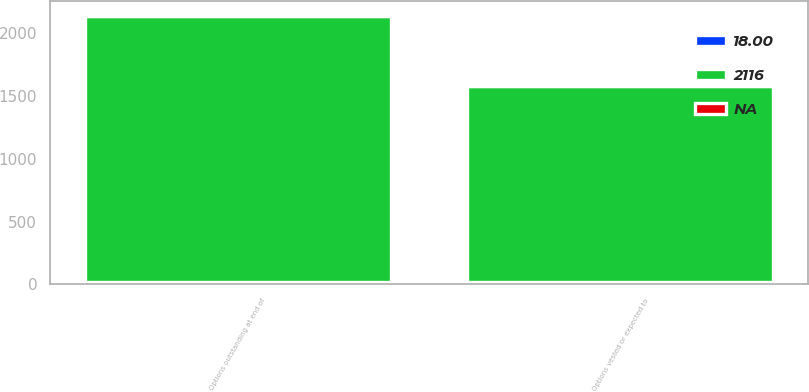Convert chart. <chart><loc_0><loc_0><loc_500><loc_500><stacked_bar_chart><ecel><fcel>Options outstanding at end of<fcel>Options vested or expected to<nl><fcel>2116<fcel>2116<fcel>1562<nl><fcel>18<fcel>18<fcel>18<nl><fcel>nan<fcel>9.96<fcel>9.96<nl></chart> 